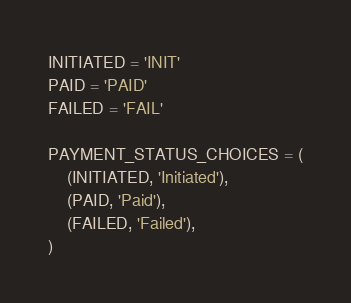<code> <loc_0><loc_0><loc_500><loc_500><_Python_>INITIATED = 'INIT'
PAID = 'PAID'
FAILED = 'FAIL'

PAYMENT_STATUS_CHOICES = (
    (INITIATED, 'Initiated'),
    (PAID, 'Paid'),
    (FAILED, 'Failed'),
)
</code> 